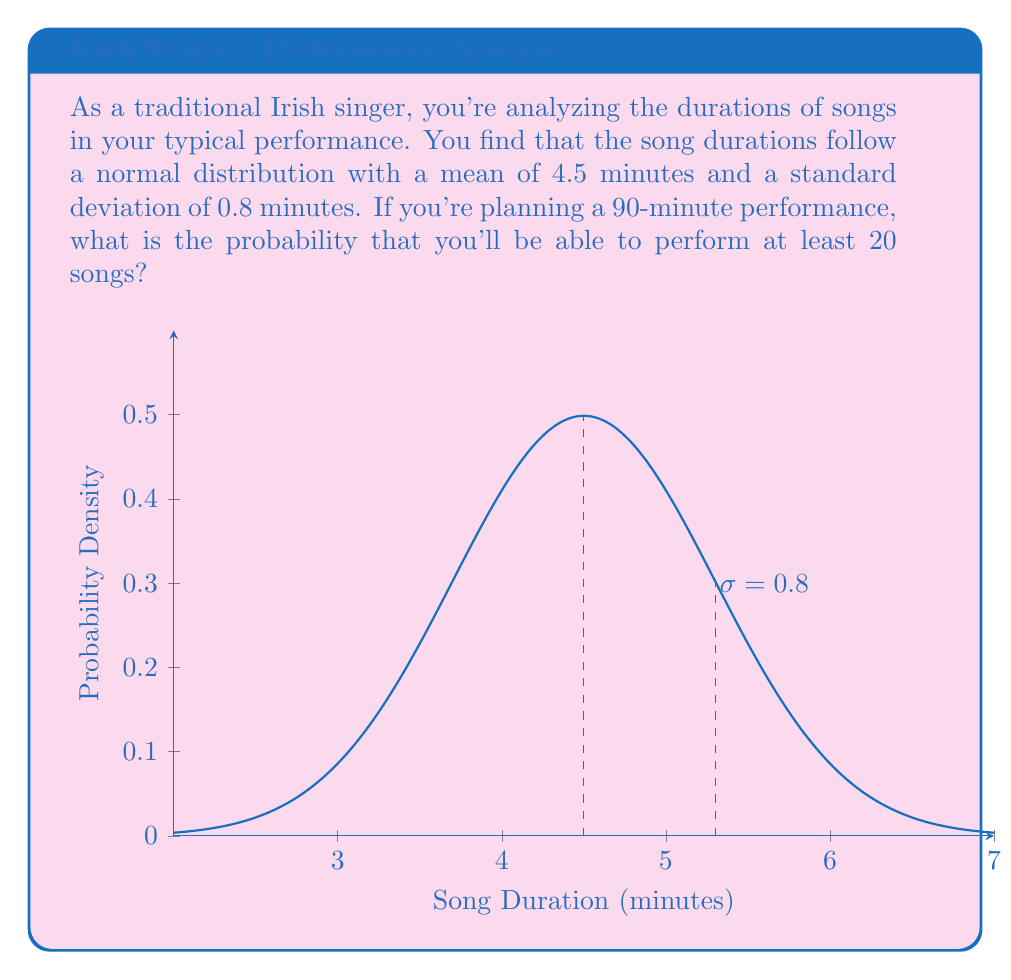Could you help me with this problem? Let's approach this step-by-step:

1) First, we need to find the maximum average duration per song that would allow for at least 20 songs in 90 minutes:

   $$\frac{90 \text{ minutes}}{20 \text{ songs}} = 4.5 \text{ minutes/song}$$

2) This coincidentally matches our mean, but we need to find the probability of a song being 4.5 minutes or shorter.

3) To do this, we use the z-score formula:

   $$z = \frac{x - \mu}{\sigma}$$

   Where $x$ is our value (4.5), $\mu$ is the mean (4.5), and $\sigma$ is the standard deviation (0.8).

4) Plugging in our values:

   $$z = \frac{4.5 - 4.5}{0.8} = 0$$

5) A z-score of 0 corresponds to the mean, which in a normal distribution is the 50th percentile.

6) This means there's a 50% chance that any given song will be 4.5 minutes or shorter.

7) However, we need the probability of this happening for all 20 songs. This is equivalent to the probability of getting 20 successes in 20 trials, where each trial has a 50% chance of success.

8) This follows a binomial distribution with $n=20$ and $p=0.5$. The probability is:

   $$P(X=20) = \binom{20}{20} * 0.5^{20} * 0.5^0 = 0.5^{20} \approx 9.54 * 10^{-7}$$

9) Therefore, the probability of being able to perform at least 20 songs is extremely low, approximately 0.0000954% or about 1 in 1,048,576.
Answer: $9.54 * 10^{-7}$ or approximately 0.0000954% 